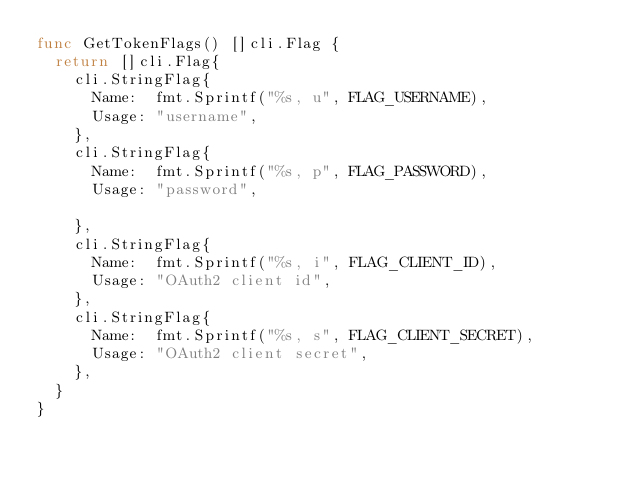Convert code to text. <code><loc_0><loc_0><loc_500><loc_500><_Go_>func GetTokenFlags() []cli.Flag {
	return []cli.Flag{
		cli.StringFlag{
			Name:  fmt.Sprintf("%s, u", FLAG_USERNAME),
			Usage: "username",
		},
		cli.StringFlag{
			Name:  fmt.Sprintf("%s, p", FLAG_PASSWORD),
			Usage: "password",

		},
		cli.StringFlag{
			Name:  fmt.Sprintf("%s, i", FLAG_CLIENT_ID),
			Usage: "OAuth2 client id",
		},
		cli.StringFlag{
			Name:  fmt.Sprintf("%s, s", FLAG_CLIENT_SECRET),
			Usage: "OAuth2 client secret",
		},
	}
}
</code> 